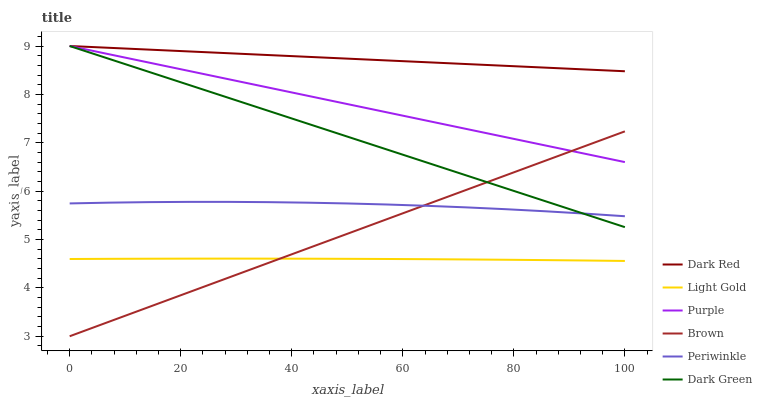Does Purple have the minimum area under the curve?
Answer yes or no. No. Does Purple have the maximum area under the curve?
Answer yes or no. No. Is Purple the smoothest?
Answer yes or no. No. Is Purple the roughest?
Answer yes or no. No. Does Purple have the lowest value?
Answer yes or no. No. Does Periwinkle have the highest value?
Answer yes or no. No. Is Brown less than Dark Red?
Answer yes or no. Yes. Is Periwinkle greater than Light Gold?
Answer yes or no. Yes. Does Brown intersect Dark Red?
Answer yes or no. No. 